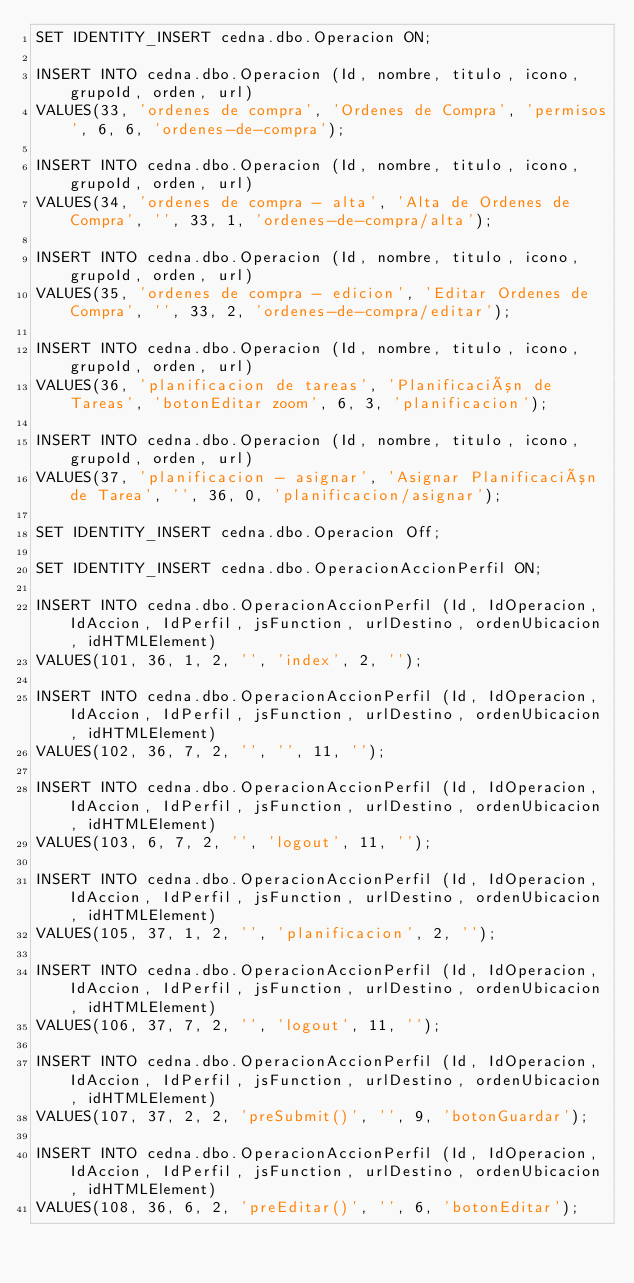<code> <loc_0><loc_0><loc_500><loc_500><_SQL_>SET IDENTITY_INSERT cedna.dbo.Operacion ON;

INSERT INTO cedna.dbo.Operacion (Id, nombre, titulo, icono, grupoId, orden, url)
VALUES(33, 'ordenes de compra', 'Ordenes de Compra', 'permisos', 6, 6, 'ordenes-de-compra');

INSERT INTO cedna.dbo.Operacion (Id, nombre, titulo, icono, grupoId, orden, url)
VALUES(34, 'ordenes de compra - alta', 'Alta de Ordenes de Compra', '', 33, 1, 'ordenes-de-compra/alta');

INSERT INTO cedna.dbo.Operacion (Id, nombre, titulo, icono, grupoId, orden, url)
VALUES(35, 'ordenes de compra - edicion', 'Editar Ordenes de Compra', '', 33, 2, 'ordenes-de-compra/editar');

INSERT INTO cedna.dbo.Operacion (Id, nombre, titulo, icono, grupoId, orden, url)
VALUES(36, 'planificacion de tareas', 'Planificación de Tareas', 'botonEditar zoom', 6, 3, 'planificacion');

INSERT INTO cedna.dbo.Operacion (Id, nombre, titulo, icono, grupoId, orden, url)
VALUES(37, 'planificacion - asignar', 'Asignar Planificación de Tarea', '', 36, 0, 'planificacion/asignar');

SET IDENTITY_INSERT cedna.dbo.Operacion Off;

SET IDENTITY_INSERT cedna.dbo.OperacionAccionPerfil ON;

INSERT INTO cedna.dbo.OperacionAccionPerfil (Id, IdOperacion, IdAccion, IdPerfil, jsFunction, urlDestino, ordenUbicacion, idHTMLElement)
VALUES(101, 36, 1, 2, '', 'index', 2, '');

INSERT INTO cedna.dbo.OperacionAccionPerfil (Id, IdOperacion, IdAccion, IdPerfil, jsFunction, urlDestino, ordenUbicacion, idHTMLElement)
VALUES(102, 36, 7, 2, '', '', 11, '');

INSERT INTO cedna.dbo.OperacionAccionPerfil (Id, IdOperacion, IdAccion, IdPerfil, jsFunction, urlDestino, ordenUbicacion, idHTMLElement)
VALUES(103, 6, 7, 2, '', 'logout', 11, '');

INSERT INTO cedna.dbo.OperacionAccionPerfil (Id, IdOperacion, IdAccion, IdPerfil, jsFunction, urlDestino, ordenUbicacion, idHTMLElement)
VALUES(105, 37, 1, 2, '', 'planificacion', 2, '');

INSERT INTO cedna.dbo.OperacionAccionPerfil (Id, IdOperacion, IdAccion, IdPerfil, jsFunction, urlDestino, ordenUbicacion, idHTMLElement)
VALUES(106, 37, 7, 2, '', 'logout', 11, '');

INSERT INTO cedna.dbo.OperacionAccionPerfil (Id, IdOperacion, IdAccion, IdPerfil, jsFunction, urlDestino, ordenUbicacion, idHTMLElement)
VALUES(107, 37, 2, 2, 'preSubmit()', '', 9, 'botonGuardar');

INSERT INTO cedna.dbo.OperacionAccionPerfil (Id, IdOperacion, IdAccion, IdPerfil, jsFunction, urlDestino, ordenUbicacion, idHTMLElement)
VALUES(108, 36, 6, 2, 'preEditar()', '', 6, 'botonEditar');

</code> 